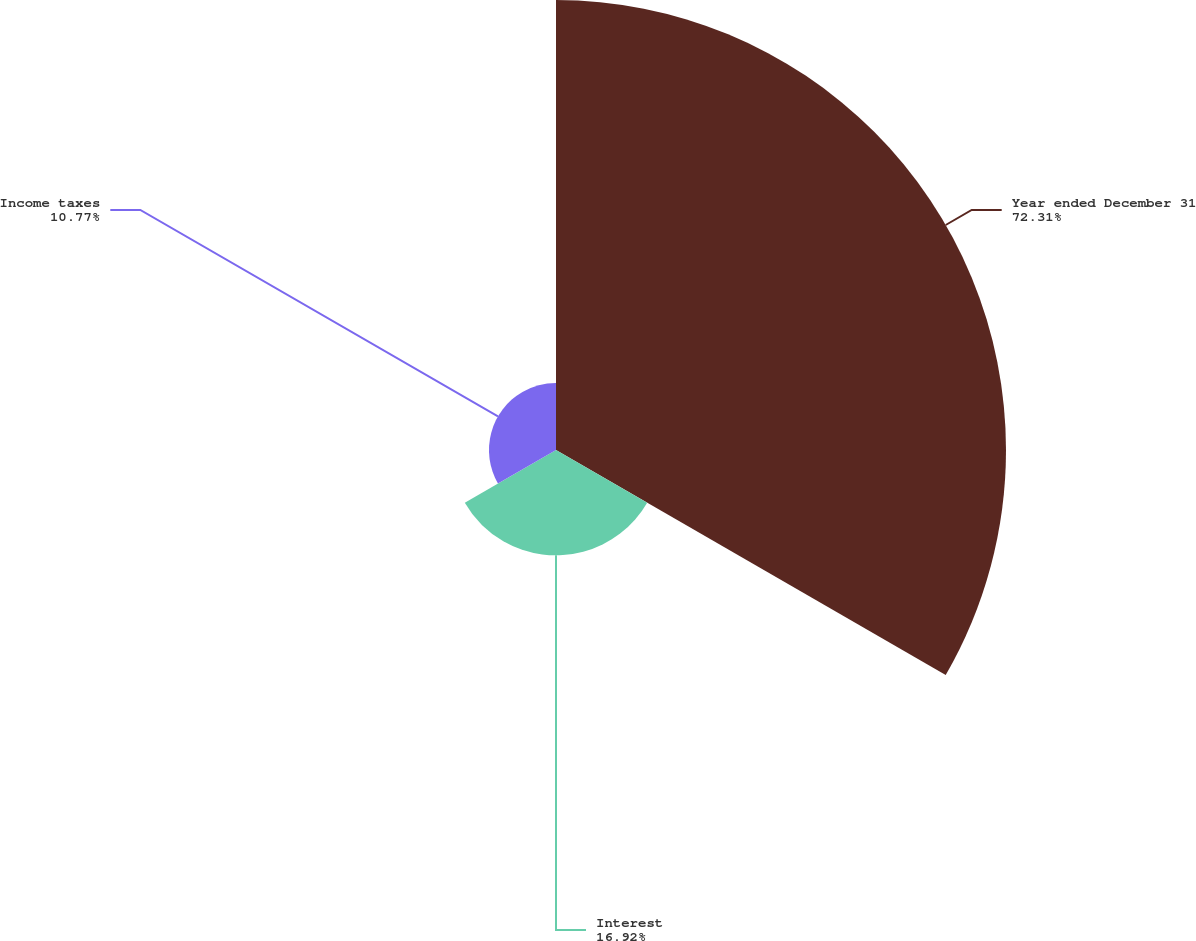Convert chart. <chart><loc_0><loc_0><loc_500><loc_500><pie_chart><fcel>Year ended December 31<fcel>Interest<fcel>Income taxes<nl><fcel>72.31%<fcel>16.92%<fcel>10.77%<nl></chart> 